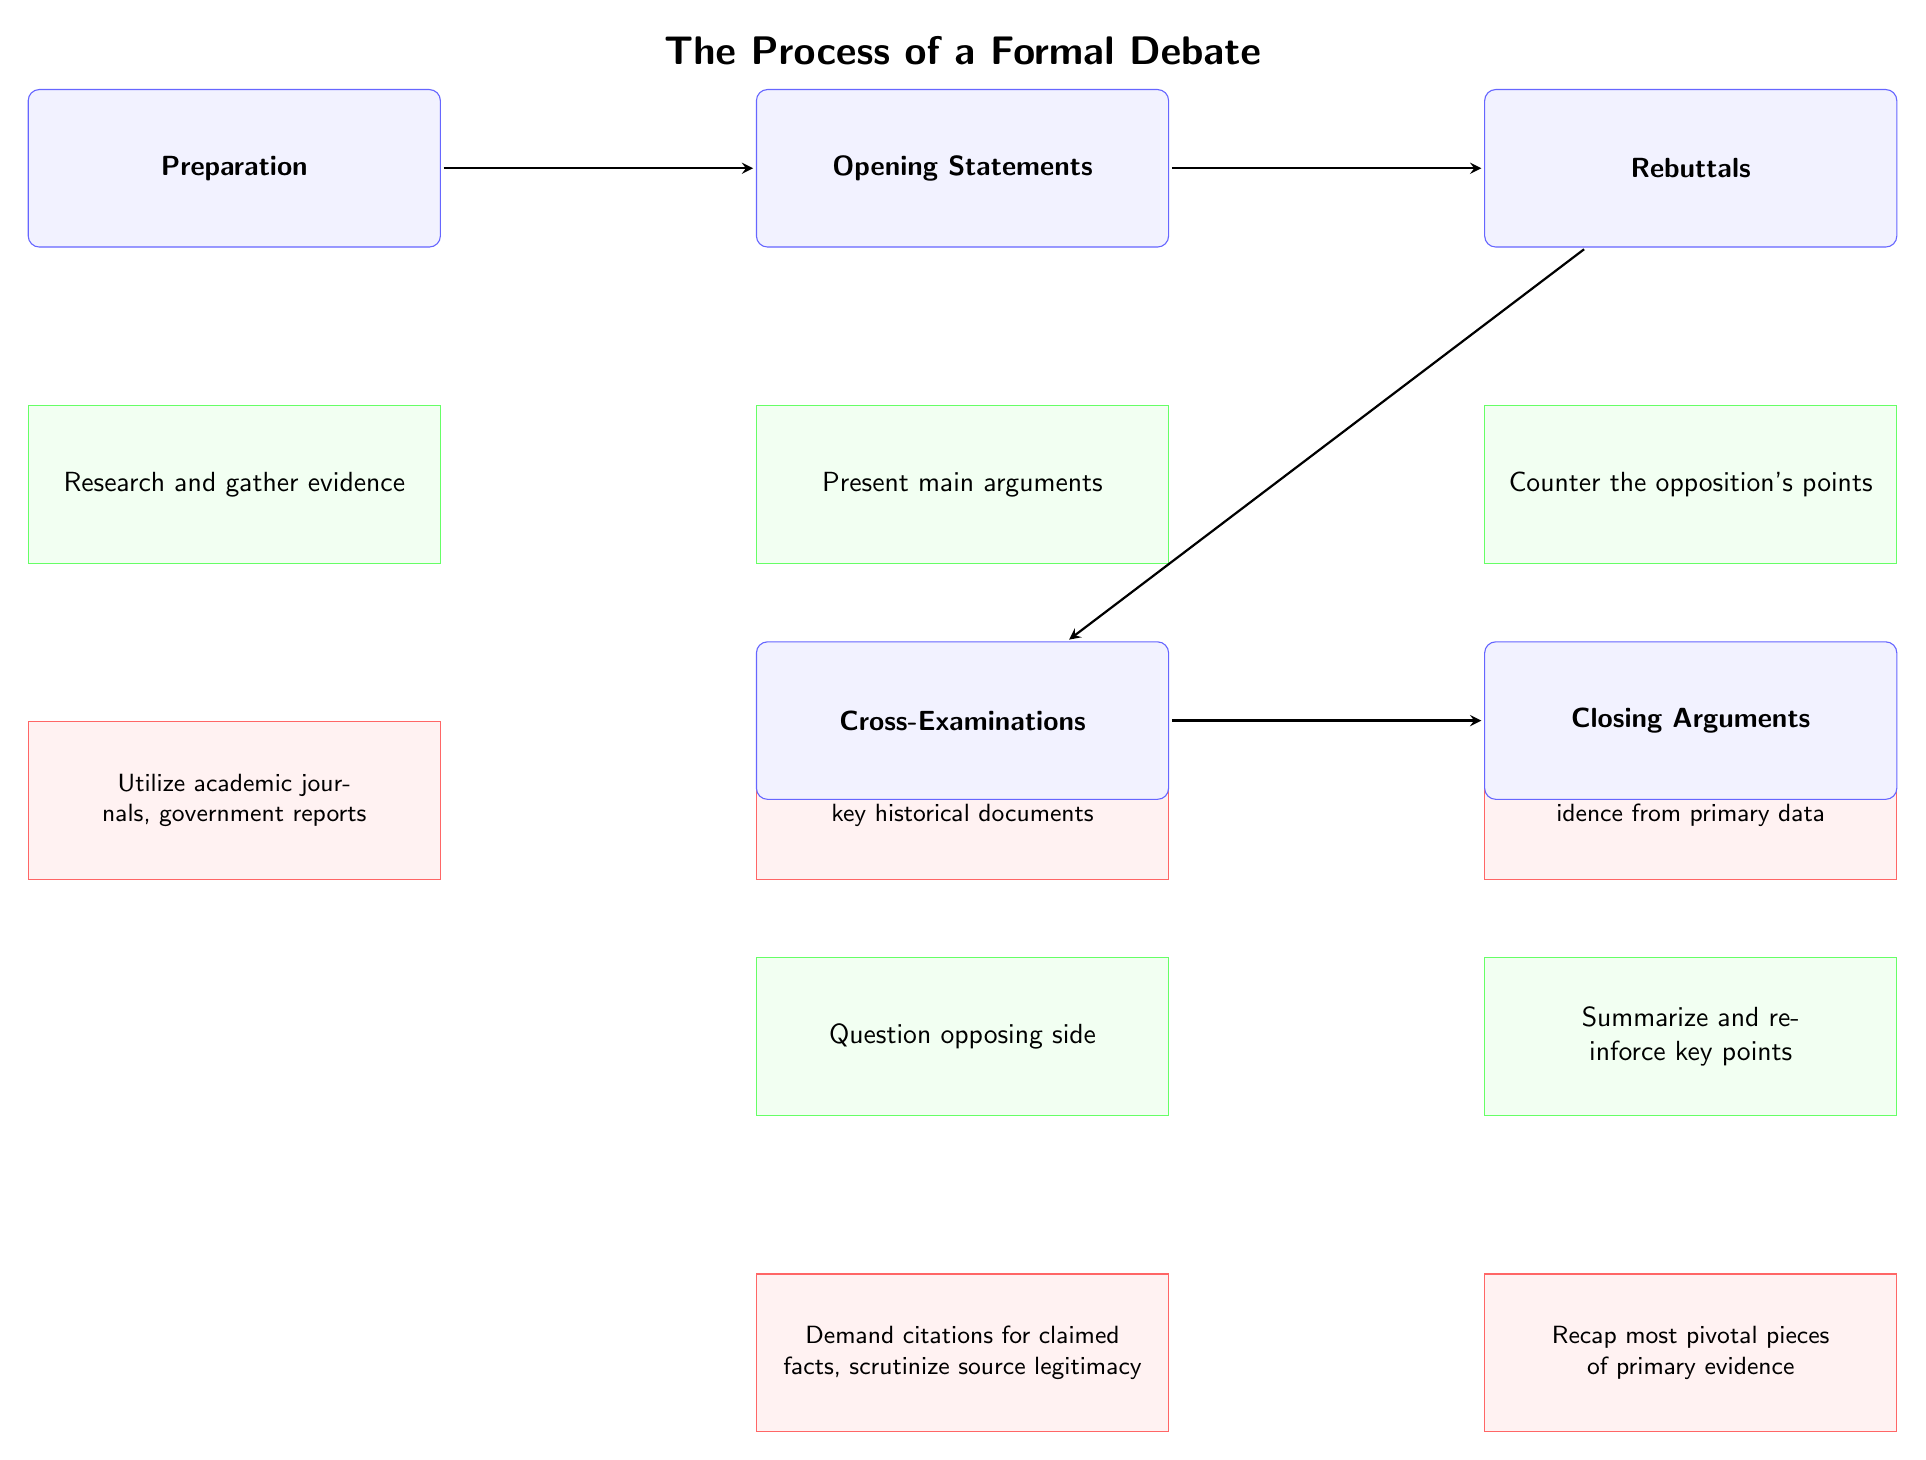What is the first stage of a formal debate? The diagram indicates that the first stage is "Preparation," as it is the topmost node representing the beginning of the debate process.
Answer: Preparation What are the primary sources suggested for the Preparation stage? In the Preparation stage, the details section lists "Utilize academic journals, government reports" as the suggested primary sources to support the arguments being formed.
Answer: Academic journals, government reports How many total stages are displayed in the diagram? The diagram shows five distinct stages: Preparation, Opening Statements, Rebuttals, Cross-Examinations, and Closing Arguments, which adds up to a total of five stages.
Answer: Five What comes after Opening Statements in the debate process? According to the flow of the diagram, the stage that follows Opening Statements is Rebuttals, as represented by the arrow pointing down to Rebuttals from Opening Statements.
Answer: Rebuttals In the Cross-Examinations stage, what is emphasized regarding source legitimacy? The Cross-Examinations details highlight the importance of scrutinizing source legitimacy, indicating that participants should "Demand citations for claimed facts." This emphasizes the critical approach needed when evaluating opposing sources.
Answer: Demand citations for claimed facts Which stage includes summarizing and reinforcing key points? The stage that includes summarizing and reinforcing key points is Closing Arguments, as stated directly in the specific details of that stage within the diagram.
Answer: Closing Arguments What type of primary evidence is required during the Closing Arguments stage? The diagram indicates that during the Closing Arguments, it’s crucial to "Recap most pivotal pieces of primary evidence," which informs participants to focus on significant data that strengthens their concluding statements.
Answer: Most pivotal pieces of primary evidence What type of questioning is involved in the Cross-Examinations stage? The diagram specifies that the type of questioning involved in the Cross-Examinations stage is to "Question opposing side," indicating an interactive component aimed at challenging the other team’s arguments.
Answer: Question opposing side What is the relationship between Rebuttals and Cross-Examinations? The diagram shows a direct progression where Rebuttals leads into Cross-Examinations, represented by an arrow connecting the two stages. This implies that after providing rebuttals, the next logical step is to engage in cross-examinations.
Answer: Rebuttals lead to Cross-Examinations 